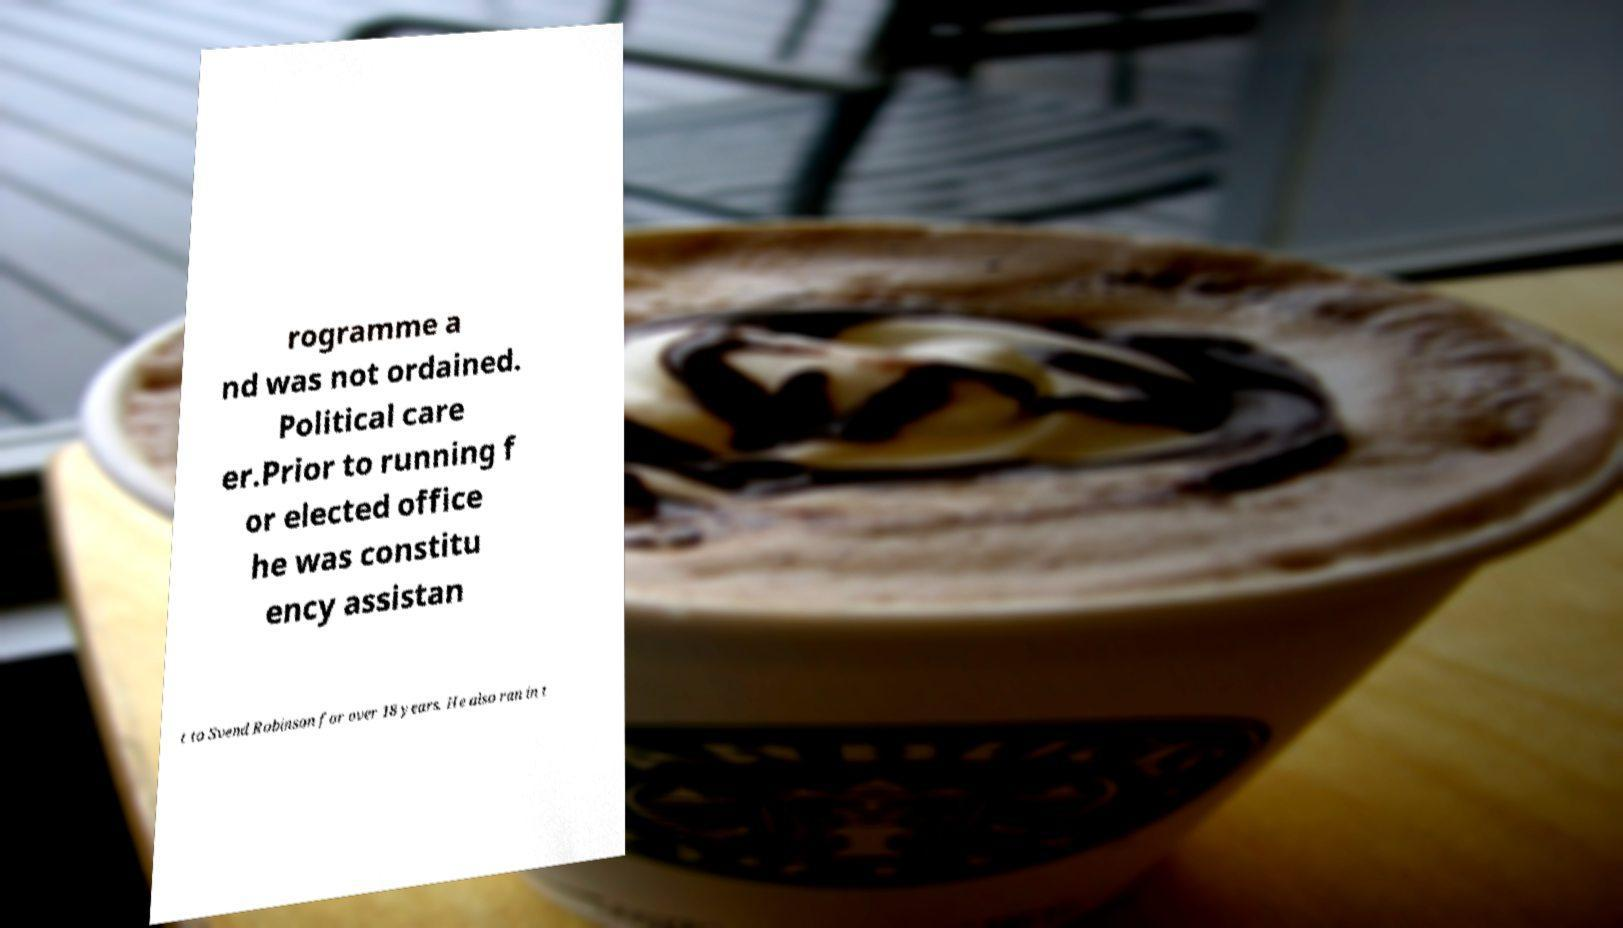Please identify and transcribe the text found in this image. rogramme a nd was not ordained. Political care er.Prior to running f or elected office he was constitu ency assistan t to Svend Robinson for over 18 years. He also ran in t 